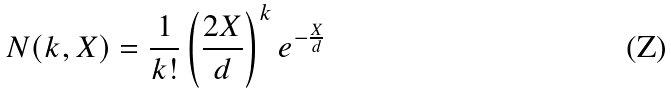Convert formula to latex. <formula><loc_0><loc_0><loc_500><loc_500>N ( k , X ) = \frac { 1 } { k ! } \left ( \frac { 2 X } { d } \right ) ^ { k } e ^ { - \frac { X } { d } }</formula> 